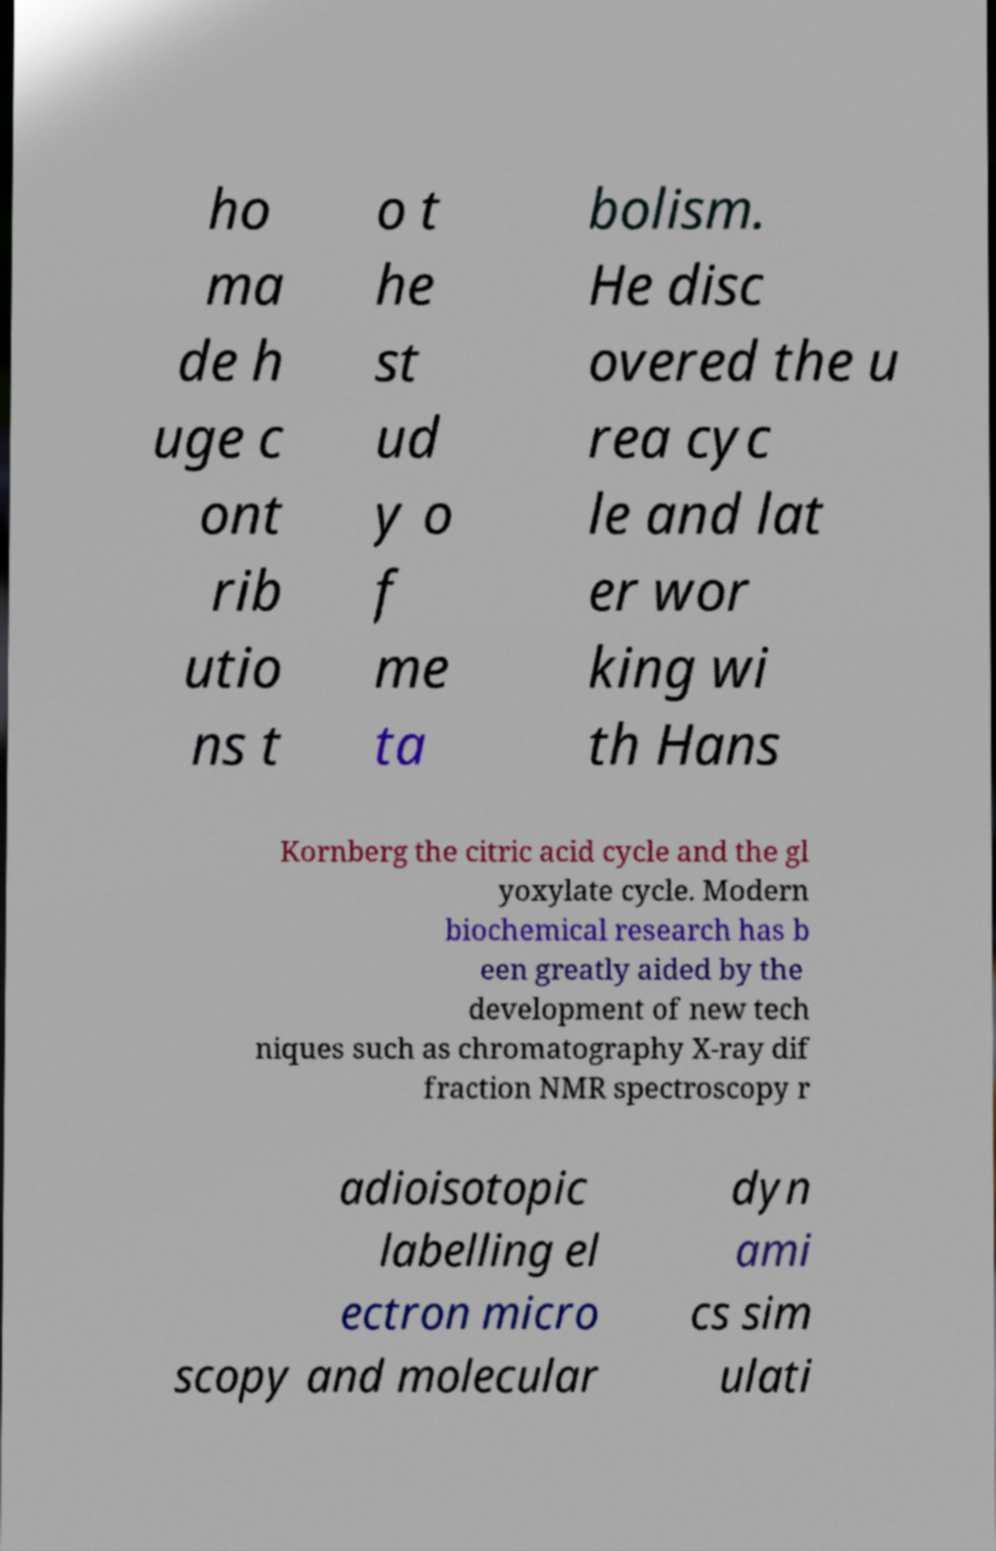What messages or text are displayed in this image? I need them in a readable, typed format. ho ma de h uge c ont rib utio ns t o t he st ud y o f me ta bolism. He disc overed the u rea cyc le and lat er wor king wi th Hans Kornberg the citric acid cycle and the gl yoxylate cycle. Modern biochemical research has b een greatly aided by the development of new tech niques such as chromatography X-ray dif fraction NMR spectroscopy r adioisotopic labelling el ectron micro scopy and molecular dyn ami cs sim ulati 